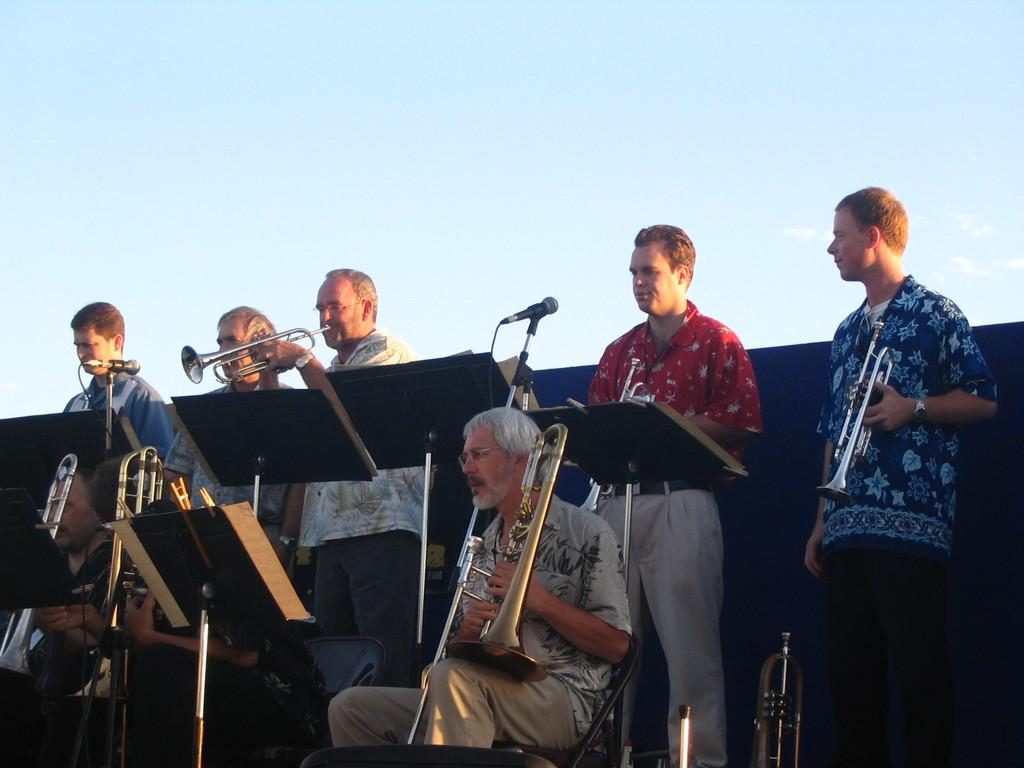What are the people in the image doing? The people in the image are playing musical instruments. What can be seen in the background of the image? There is a banner and the sky visible in the background of the image. What type of door can be seen in the image? There is no door present in the image. What kind of playground equipment is visible in the image? There is no playground equipment present in the image. 